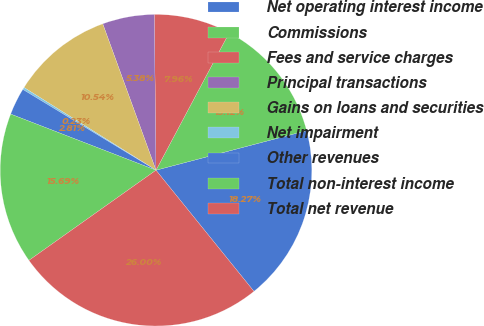Convert chart. <chart><loc_0><loc_0><loc_500><loc_500><pie_chart><fcel>Net operating interest income<fcel>Commissions<fcel>Fees and service charges<fcel>Principal transactions<fcel>Gains on loans and securities<fcel>Net impairment<fcel>Other revenues<fcel>Total non-interest income<fcel>Total net revenue<nl><fcel>18.27%<fcel>13.12%<fcel>7.96%<fcel>5.38%<fcel>10.54%<fcel>0.23%<fcel>2.81%<fcel>15.69%<fcel>26.0%<nl></chart> 